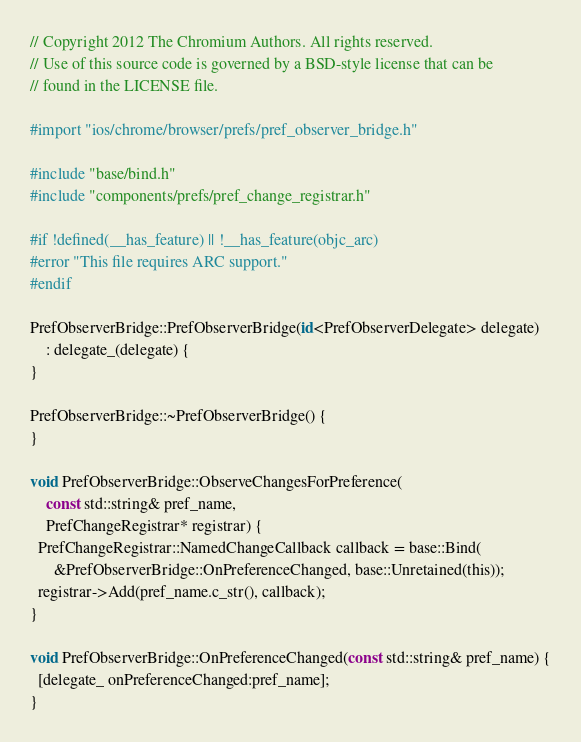Convert code to text. <code><loc_0><loc_0><loc_500><loc_500><_ObjectiveC_>// Copyright 2012 The Chromium Authors. All rights reserved.
// Use of this source code is governed by a BSD-style license that can be
// found in the LICENSE file.

#import "ios/chrome/browser/prefs/pref_observer_bridge.h"

#include "base/bind.h"
#include "components/prefs/pref_change_registrar.h"

#if !defined(__has_feature) || !__has_feature(objc_arc)
#error "This file requires ARC support."
#endif

PrefObserverBridge::PrefObserverBridge(id<PrefObserverDelegate> delegate)
    : delegate_(delegate) {
}

PrefObserverBridge::~PrefObserverBridge() {
}

void PrefObserverBridge::ObserveChangesForPreference(
    const std::string& pref_name,
    PrefChangeRegistrar* registrar) {
  PrefChangeRegistrar::NamedChangeCallback callback = base::Bind(
      &PrefObserverBridge::OnPreferenceChanged, base::Unretained(this));
  registrar->Add(pref_name.c_str(), callback);
}

void PrefObserverBridge::OnPreferenceChanged(const std::string& pref_name) {
  [delegate_ onPreferenceChanged:pref_name];
}
</code> 